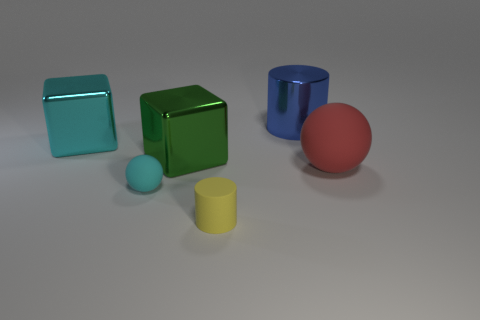Add 1 tiny brown shiny cubes. How many objects exist? 7 Subtract all cylinders. How many objects are left? 4 Subtract all yellow cylinders. How many cylinders are left? 1 Subtract 0 gray cubes. How many objects are left? 6 Subtract all cyan cylinders. Subtract all cyan cubes. How many cylinders are left? 2 Subtract all tiny purple blocks. Subtract all large cyan objects. How many objects are left? 5 Add 2 cyan spheres. How many cyan spheres are left? 3 Add 3 cyan matte objects. How many cyan matte objects exist? 4 